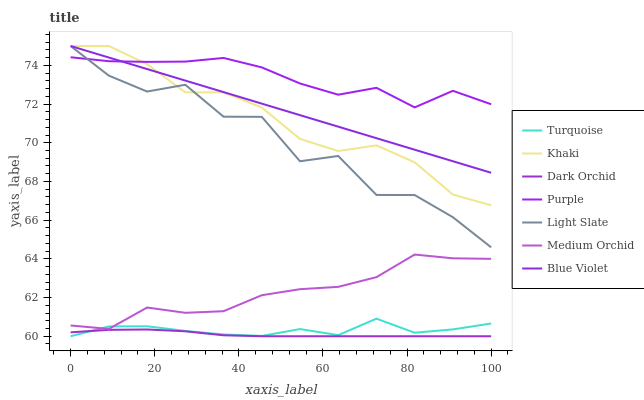Does Dark Orchid have the minimum area under the curve?
Answer yes or no. Yes. Does Purple have the maximum area under the curve?
Answer yes or no. Yes. Does Khaki have the minimum area under the curve?
Answer yes or no. No. Does Khaki have the maximum area under the curve?
Answer yes or no. No. Is Blue Violet the smoothest?
Answer yes or no. Yes. Is Light Slate the roughest?
Answer yes or no. Yes. Is Khaki the smoothest?
Answer yes or no. No. Is Khaki the roughest?
Answer yes or no. No. Does Turquoise have the lowest value?
Answer yes or no. Yes. Does Khaki have the lowest value?
Answer yes or no. No. Does Blue Violet have the highest value?
Answer yes or no. Yes. Does Purple have the highest value?
Answer yes or no. No. Is Medium Orchid less than Light Slate?
Answer yes or no. Yes. Is Light Slate greater than Dark Orchid?
Answer yes or no. Yes. Does Turquoise intersect Dark Orchid?
Answer yes or no. Yes. Is Turquoise less than Dark Orchid?
Answer yes or no. No. Is Turquoise greater than Dark Orchid?
Answer yes or no. No. Does Medium Orchid intersect Light Slate?
Answer yes or no. No. 